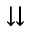<formula> <loc_0><loc_0><loc_500><loc_500>\downdownarrows</formula> 